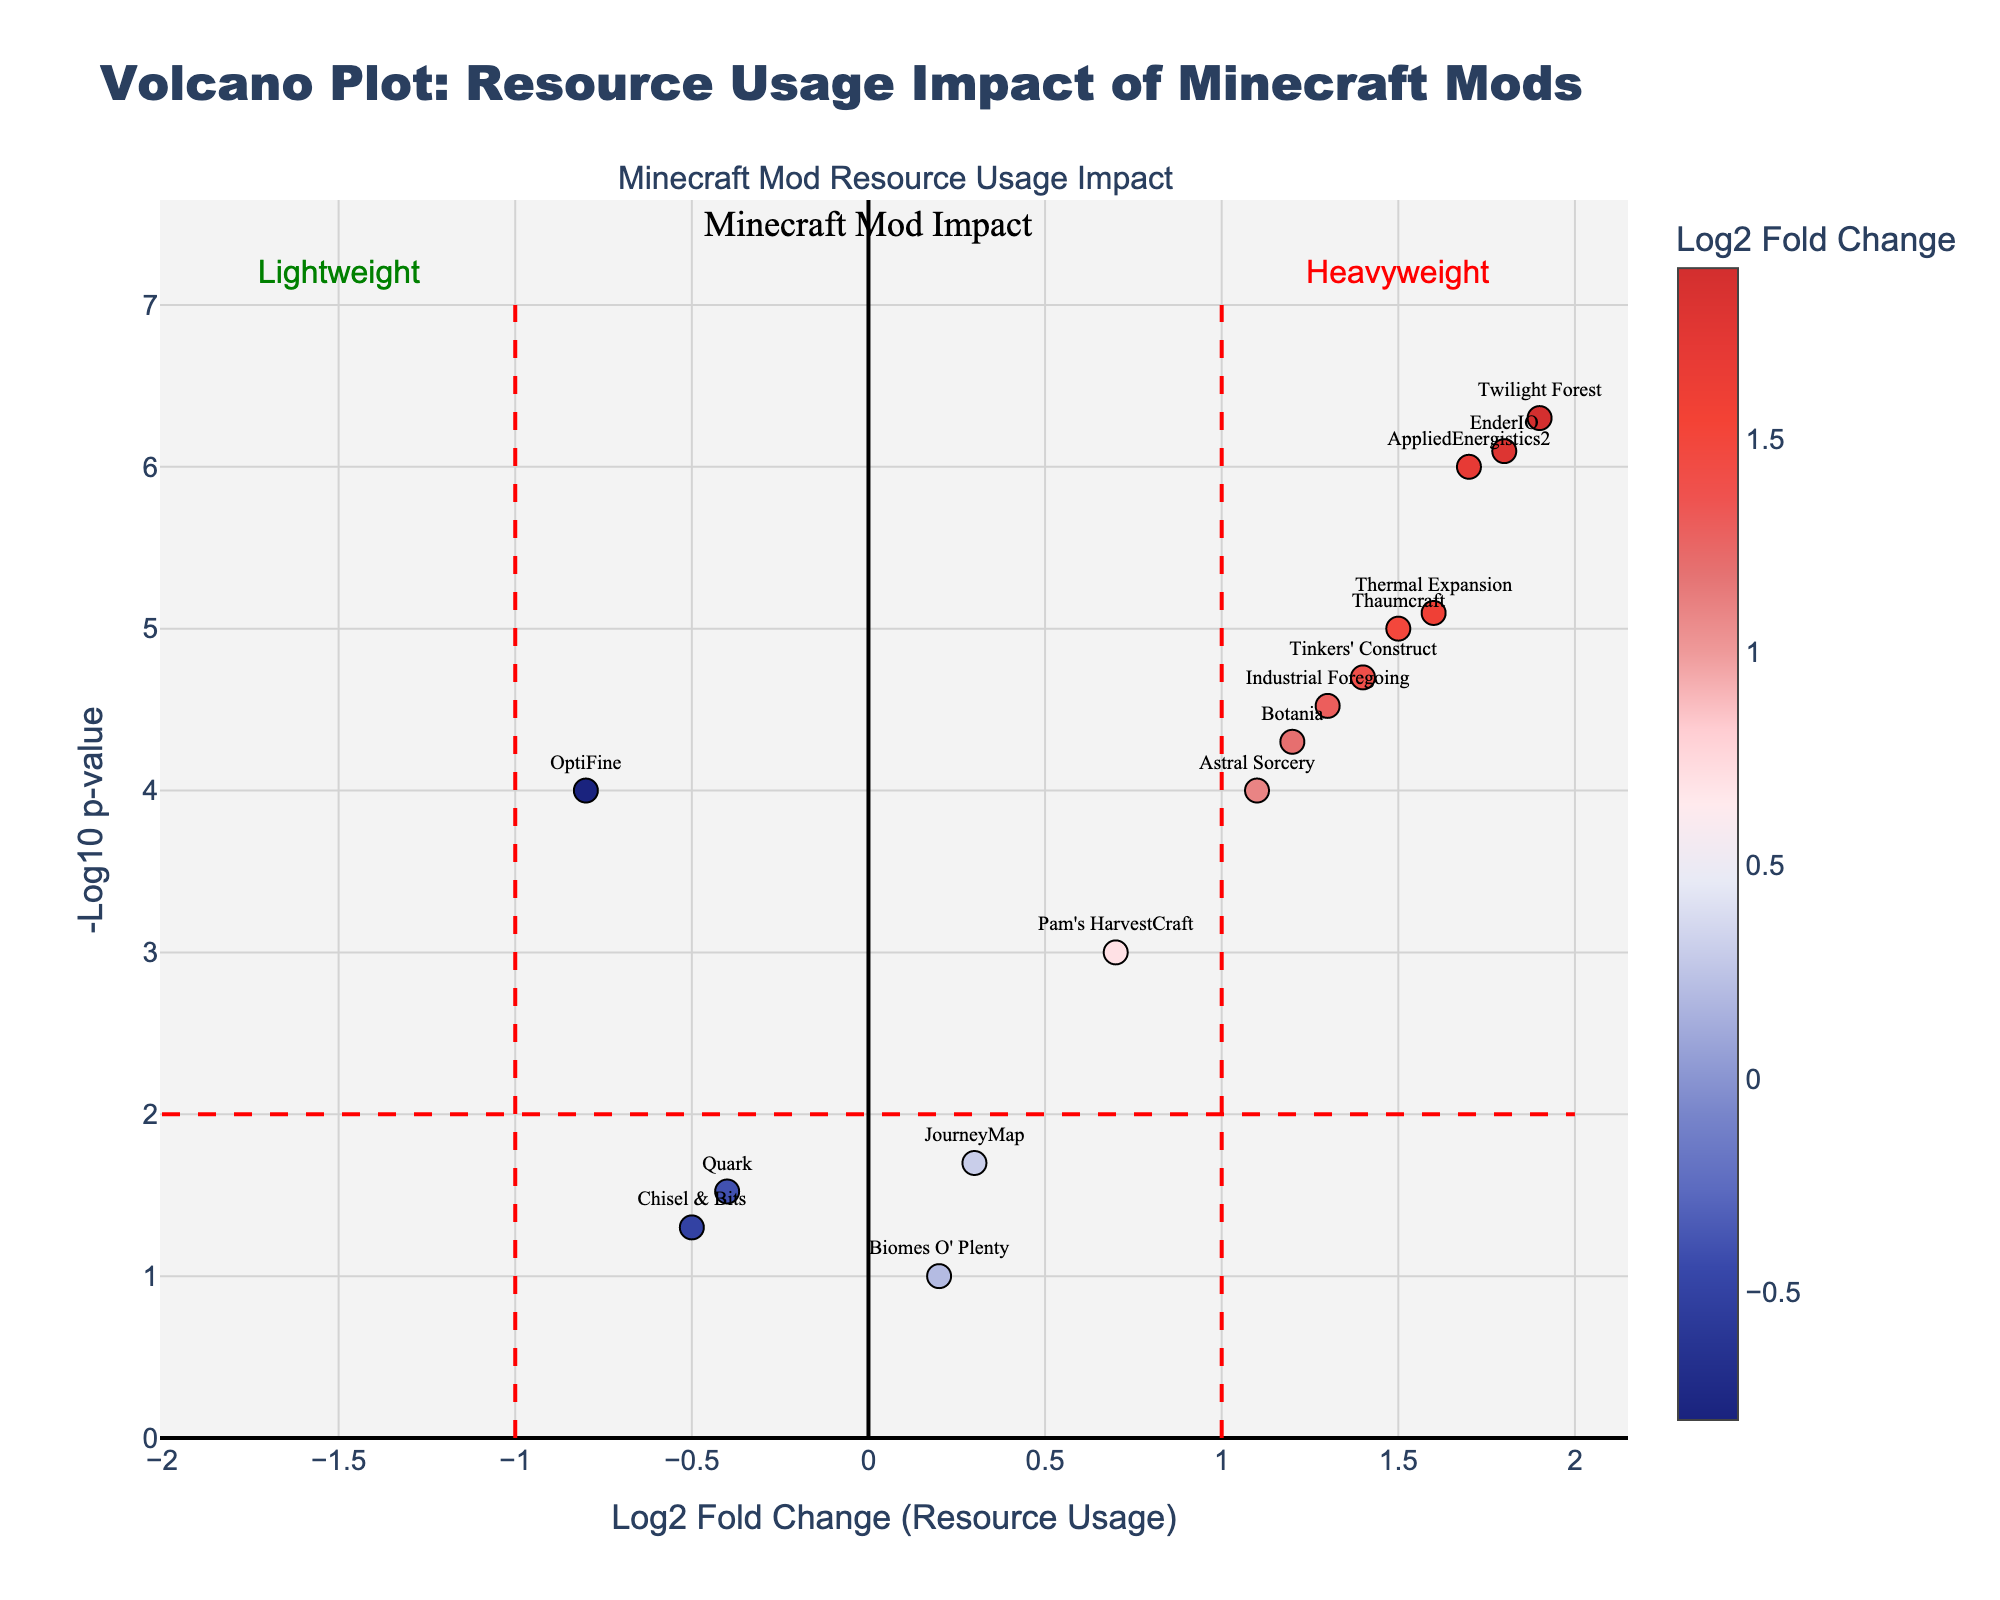What's the title of the figure? The title is usually in bold text at the top of the chart. It summarizes the chart's purpose, so looking at the top, we can see the title.
Answer: Volcano Plot: Resource Usage Impact of Minecraft Mods Which mod has the highest Log2 Fold Change? The data point with the highest x-value represents the highest Log2 Fold Change. By examining the rightmost data point on the x-axis, we identify the mod name linked to it.
Answer: Twilight Forest How many mods have a Log2 Fold Change greater than 1? Count the number of points positioned to the right of x=1 on the x-axis. These points indicate mods with a Log2 Fold Change greater than 1.
Answer: 7 Which mod has the lowest p-value? The data point that is highest on the y-axis corresponds to the lowest p-value in the figure. We look for the highest vertical data point to identify the mod.
Answer: AppliedEnergistics2 Is the mod 'Botania' considered lightweight or heavyweight? Determine the mod's position in relation to the vertical line at x=0. If it's to the right, it's heavyweight; if to the left, it's lightweight.
Answer: Heavyweight Which mods have a -Log10 p-value above 6? Identify the points positioned above y = 6 on the y-axis. Check which mods they represent in the plot.
Answer: Twilight Forest and EnderIO Compare the CPU impact between 'Tinkers' Construct' and 'OptiFine'. Assess the relative positions of these mods along the x-axis. 'Tinkers' Construct' is to the right of 'OptiFine', suggesting higher CPU usage.
Answer: 'Tinkers' Construct' has a higher CPU impact How many mods are considered lightweight? Lightweight mods are to the left of the vertical line at x=0. Count the points lying in the negative Log2 Fold Change region.
Answer: 3 Which mod has a -Log10 p-value closest to 4? Check for the data point nearest to the y-value of 4 to determine the closest mod.
Answer: Thermal Expansion What does the dashed red line at y=2 signify? Lines in plots usually denote significance thresholds. Here, the line at y=2 likely marks where the p-value is < 0.01, indicating higher statistical significance.
Answer: Statistical significance threshold 